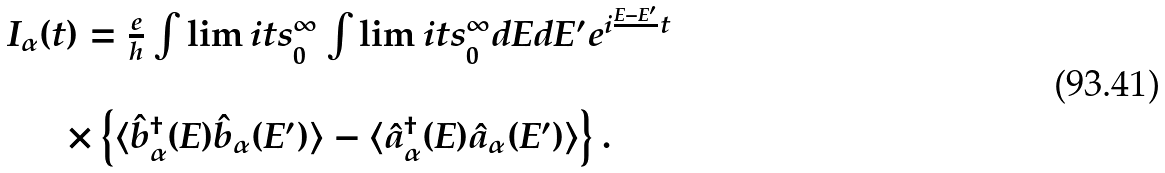Convert formula to latex. <formula><loc_0><loc_0><loc_500><loc_500>\begin{array} { c } I _ { \alpha } ( t ) = \frac { e } { h } \int \lim i t s _ { 0 } ^ { \infty } \int \lim i t s _ { 0 } ^ { \infty } d E d E ^ { \prime } e ^ { i \frac { E - E ^ { \prime } } { } t } \\ \ \\ \times \left \{ \langle \hat { b } ^ { \dagger } _ { \alpha } ( E ) \hat { b } _ { \alpha } ( E ^ { \prime } ) \rangle - \langle \hat { a } ^ { \dagger } _ { \alpha } ( E ) \hat { a } _ { \alpha } ( E ^ { \prime } ) \rangle \right \} . \end{array}</formula> 